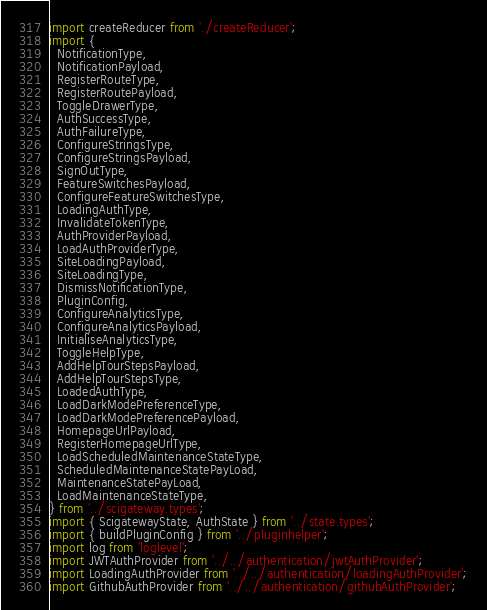<code> <loc_0><loc_0><loc_500><loc_500><_TypeScript_>import createReducer from './createReducer';
import {
  NotificationType,
  NotificationPayload,
  RegisterRouteType,
  RegisterRoutePayload,
  ToggleDrawerType,
  AuthSuccessType,
  AuthFailureType,
  ConfigureStringsType,
  ConfigureStringsPayload,
  SignOutType,
  FeatureSwitchesPayload,
  ConfigureFeatureSwitchesType,
  LoadingAuthType,
  InvalidateTokenType,
  AuthProviderPayload,
  LoadAuthProviderType,
  SiteLoadingPayload,
  SiteLoadingType,
  DismissNotificationType,
  PluginConfig,
  ConfigureAnalyticsType,
  ConfigureAnalyticsPayload,
  InitialiseAnalyticsType,
  ToggleHelpType,
  AddHelpTourStepsPayload,
  AddHelpTourStepsType,
  LoadedAuthType,
  LoadDarkModePreferenceType,
  LoadDarkModePreferencePayload,
  HomepageUrlPayload,
  RegisterHomepageUrlType,
  LoadScheduledMaintenanceStateType,
  ScheduledMaintenanceStatePayLoad,
  MaintenanceStatePayLoad,
  LoadMaintenanceStateType,
} from '../scigateway.types';
import { ScigatewayState, AuthState } from '../state.types';
import { buildPluginConfig } from '../pluginhelper';
import log from 'loglevel';
import JWTAuthProvider from '../../authentication/jwtAuthProvider';
import LoadingAuthProvider from '../../authentication/loadingAuthProvider';
import GithubAuthProvider from '../../authentication/githubAuthProvider';</code> 